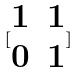<formula> <loc_0><loc_0><loc_500><loc_500>[ \begin{matrix} 1 & 1 \\ 0 & 1 \end{matrix} ]</formula> 